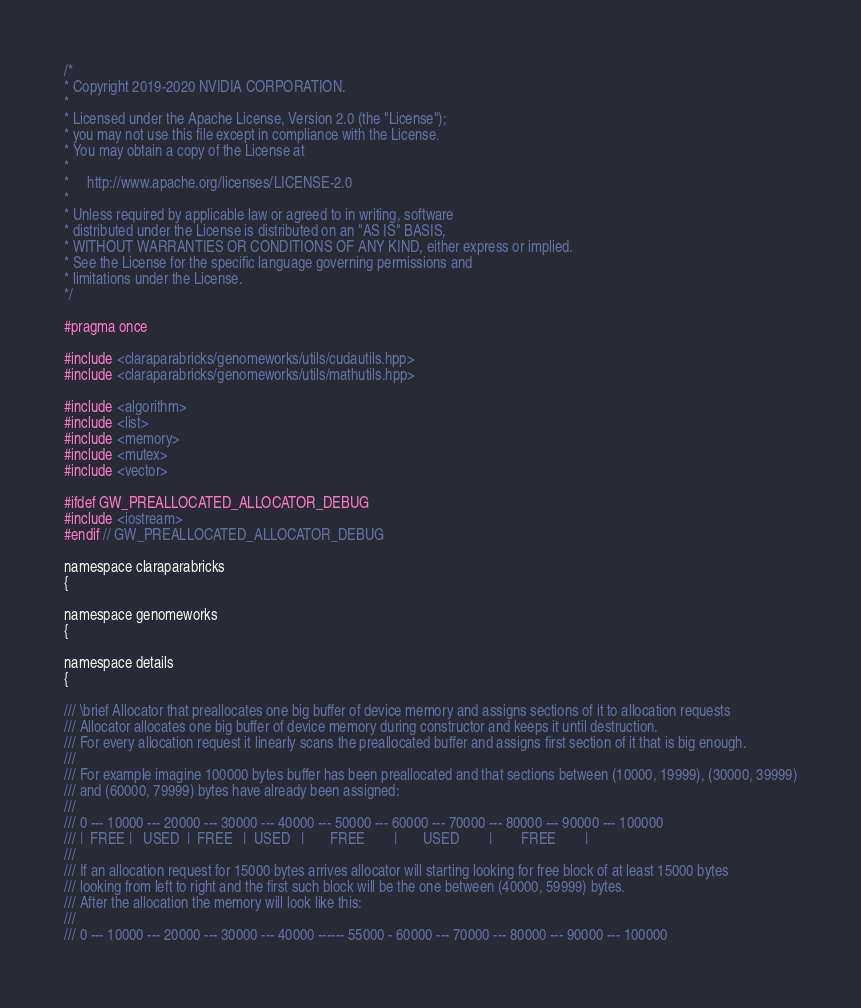Convert code to text. <code><loc_0><loc_0><loc_500><loc_500><_Cuda_>/*
* Copyright 2019-2020 NVIDIA CORPORATION.
*
* Licensed under the Apache License, Version 2.0 (the "License");
* you may not use this file except in compliance with the License.
* You may obtain a copy of the License at
*
*     http://www.apache.org/licenses/LICENSE-2.0
*
* Unless required by applicable law or agreed to in writing, software
* distributed under the License is distributed on an "AS IS" BASIS,
* WITHOUT WARRANTIES OR CONDITIONS OF ANY KIND, either express or implied.
* See the License for the specific language governing permissions and
* limitations under the License.
*/

#pragma once

#include <claraparabricks/genomeworks/utils/cudautils.hpp>
#include <claraparabricks/genomeworks/utils/mathutils.hpp>

#include <algorithm>
#include <list>
#include <memory>
#include <mutex>
#include <vector>

#ifdef GW_PREALLOCATED_ALLOCATOR_DEBUG
#include <iostream>
#endif // GW_PREALLOCATED_ALLOCATOR_DEBUG

namespace claraparabricks
{

namespace genomeworks
{

namespace details
{

/// \brief Allocator that preallocates one big buffer of device memory and assigns sections of it to allocation requests
/// Allocator allocates one big buffer of device memory during constructor and keeps it until destruction.
/// For every allocation request it linearly scans the preallocated buffer and assigns first section of it that is big enough.
///
/// For example imagine 100000 bytes buffer has been preallocated and that sections between (10000, 19999), (30000, 39999)
/// and (60000, 79999) bytes have already been assigned:
///
/// 0 --- 10000 --- 20000 --- 30000 --- 40000 --- 50000 --- 60000 --- 70000 --- 80000 --- 90000 --- 100000
/// |  FREE |   USED  |  FREE   |  USED   |       FREE        |       USED        |        FREE        |
///
/// If an allocation request for 15000 bytes arrives allocator will starting looking for free block of at least 15000 bytes
/// looking from left to right and the first such block will be the one between (40000, 59999) bytes.
/// After the allocation the memory will look like this:
///
/// 0 --- 10000 --- 20000 --- 30000 --- 40000 ------ 55000 - 60000 --- 70000 --- 80000 --- 90000 --- 100000</code> 